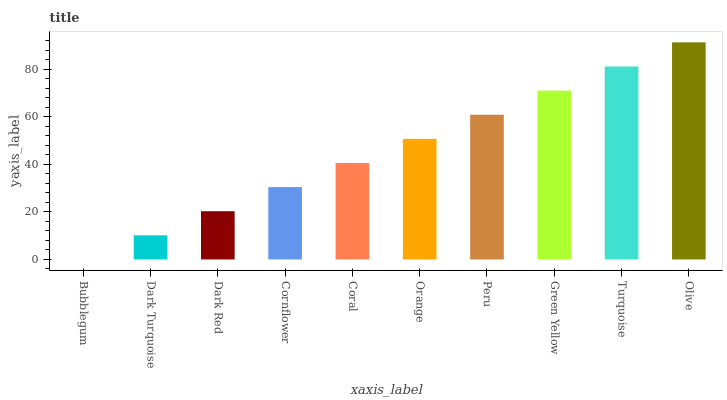Is Bubblegum the minimum?
Answer yes or no. Yes. Is Olive the maximum?
Answer yes or no. Yes. Is Dark Turquoise the minimum?
Answer yes or no. No. Is Dark Turquoise the maximum?
Answer yes or no. No. Is Dark Turquoise greater than Bubblegum?
Answer yes or no. Yes. Is Bubblegum less than Dark Turquoise?
Answer yes or no. Yes. Is Bubblegum greater than Dark Turquoise?
Answer yes or no. No. Is Dark Turquoise less than Bubblegum?
Answer yes or no. No. Is Orange the high median?
Answer yes or no. Yes. Is Coral the low median?
Answer yes or no. Yes. Is Turquoise the high median?
Answer yes or no. No. Is Dark Turquoise the low median?
Answer yes or no. No. 